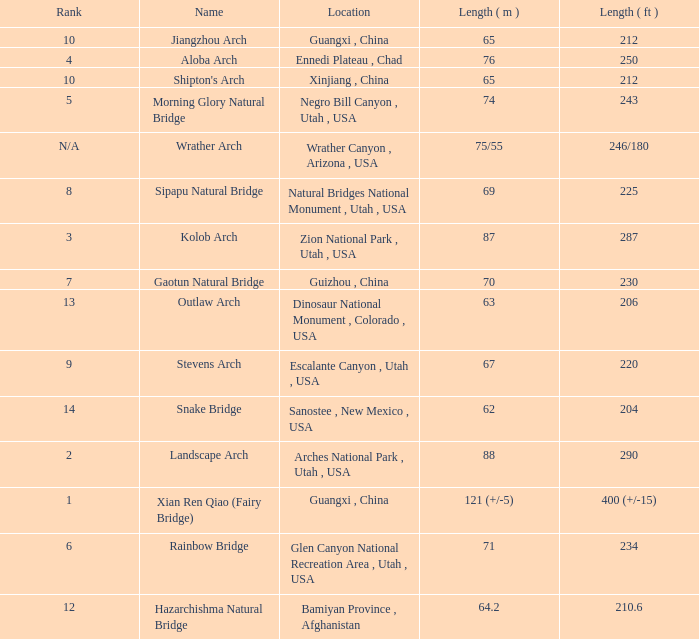Where is the longest arch with a length in meters of 63? Dinosaur National Monument , Colorado , USA. 